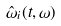Convert formula to latex. <formula><loc_0><loc_0><loc_500><loc_500>\hat { \omega } _ { i } ( t , \omega )</formula> 